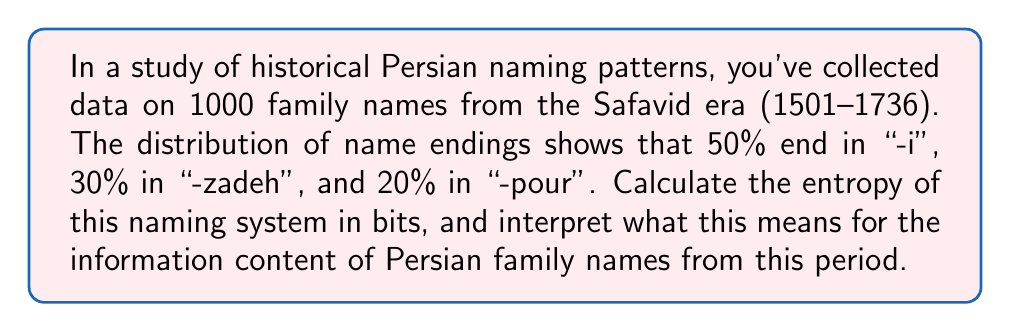Can you answer this question? To solve this problem, we'll use the concept of entropy from information theory. Entropy measures the average amount of information contained in each event of a random variable. In this case, our events are the different name endings.

Step 1: Identify the probabilities
Let's define our probabilities:
$p_1 = 0.5$ (probability of "-i")
$p_2 = 0.3$ (probability of "-zadeh")
$p_3 = 0.2$ (probability of "-pour")

Step 2: Apply the entropy formula
The entropy H is given by:

$$H = -\sum_{i=1}^n p_i \log_2(p_i)$$

Where $n$ is the number of possible outcomes (3 in this case).

Step 3: Calculate each term
$-p_1 \log_2(p_1) = -0.5 \log_2(0.5) \approx 0.5$
$-p_2 \log_2(p_2) = -0.3 \log_2(0.3) \approx 0.521$
$-p_3 \log_2(p_3) = -0.2 \log_2(0.2) \approx 0.464$

Step 4: Sum the terms
$H = 0.5 + 0.521 + 0.464 = 1.485$ bits

Interpretation: The entropy of 1.485 bits means that, on average, each family name ending in this system contains about 1.485 bits of information. This is less than the maximum possible entropy for a system with three outcomes (which would be $\log_2(3) \approx 1.585$ bits), indicating some predictability in the naming patterns. However, it's still relatively high, suggesting a good amount of diversity in family name endings during the Safavid era.
Answer: 1.485 bits 